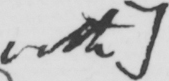Transcribe the text shown in this historical manuscript line. with  ] 